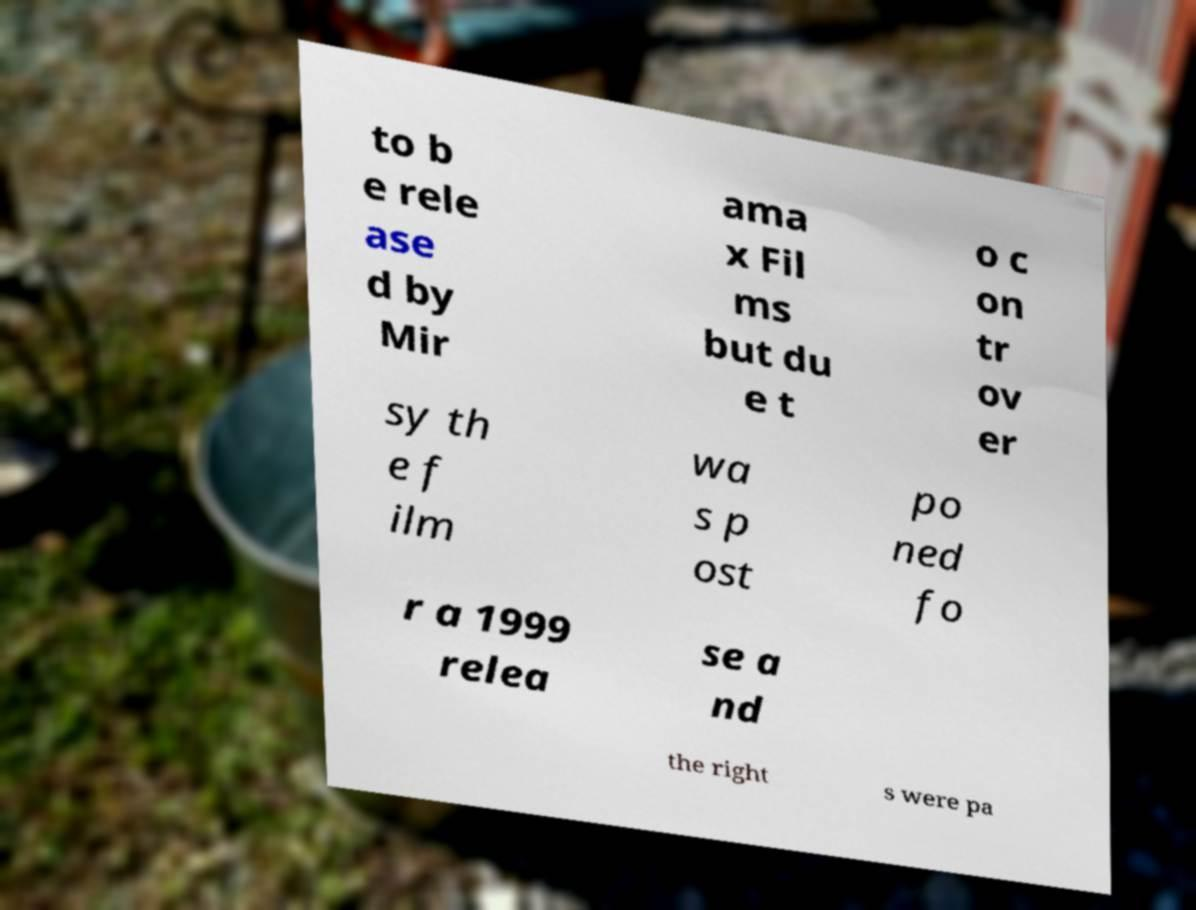There's text embedded in this image that I need extracted. Can you transcribe it verbatim? to b e rele ase d by Mir ama x Fil ms but du e t o c on tr ov er sy th e f ilm wa s p ost po ned fo r a 1999 relea se a nd the right s were pa 